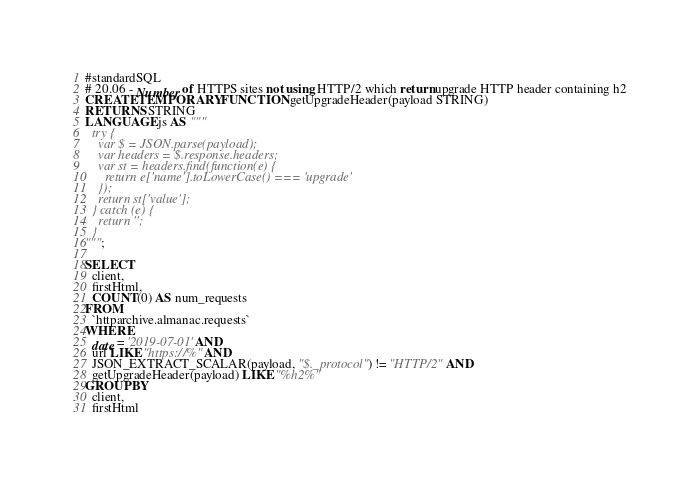Convert code to text. <code><loc_0><loc_0><loc_500><loc_500><_SQL_>#standardSQL
# 20.06 - Number of HTTPS sites not using HTTP/2 which return upgrade HTTP header containing h2
CREATE TEMPORARY FUNCTION getUpgradeHeader(payload STRING)
RETURNS STRING
LANGUAGE js AS """
  try {
    var $ = JSON.parse(payload);
    var headers = $.response.headers;
    var st = headers.find(function(e) {
      return e['name'].toLowerCase() === 'upgrade'
    });
    return st['value'];
  } catch (e) {
    return '';
  }
""";

SELECT
  client,
  firstHtml,
  COUNT(0) AS num_requests
FROM
  `httparchive.almanac.requests`
WHERE
  date = '2019-07-01' AND
  url LIKE "https://%" AND
  JSON_EXTRACT_SCALAR(payload, "$._protocol") != "HTTP/2" AND
  getUpgradeHeader(payload) LIKE "%h2%"
GROUP BY
  client,
  firstHtml
</code> 